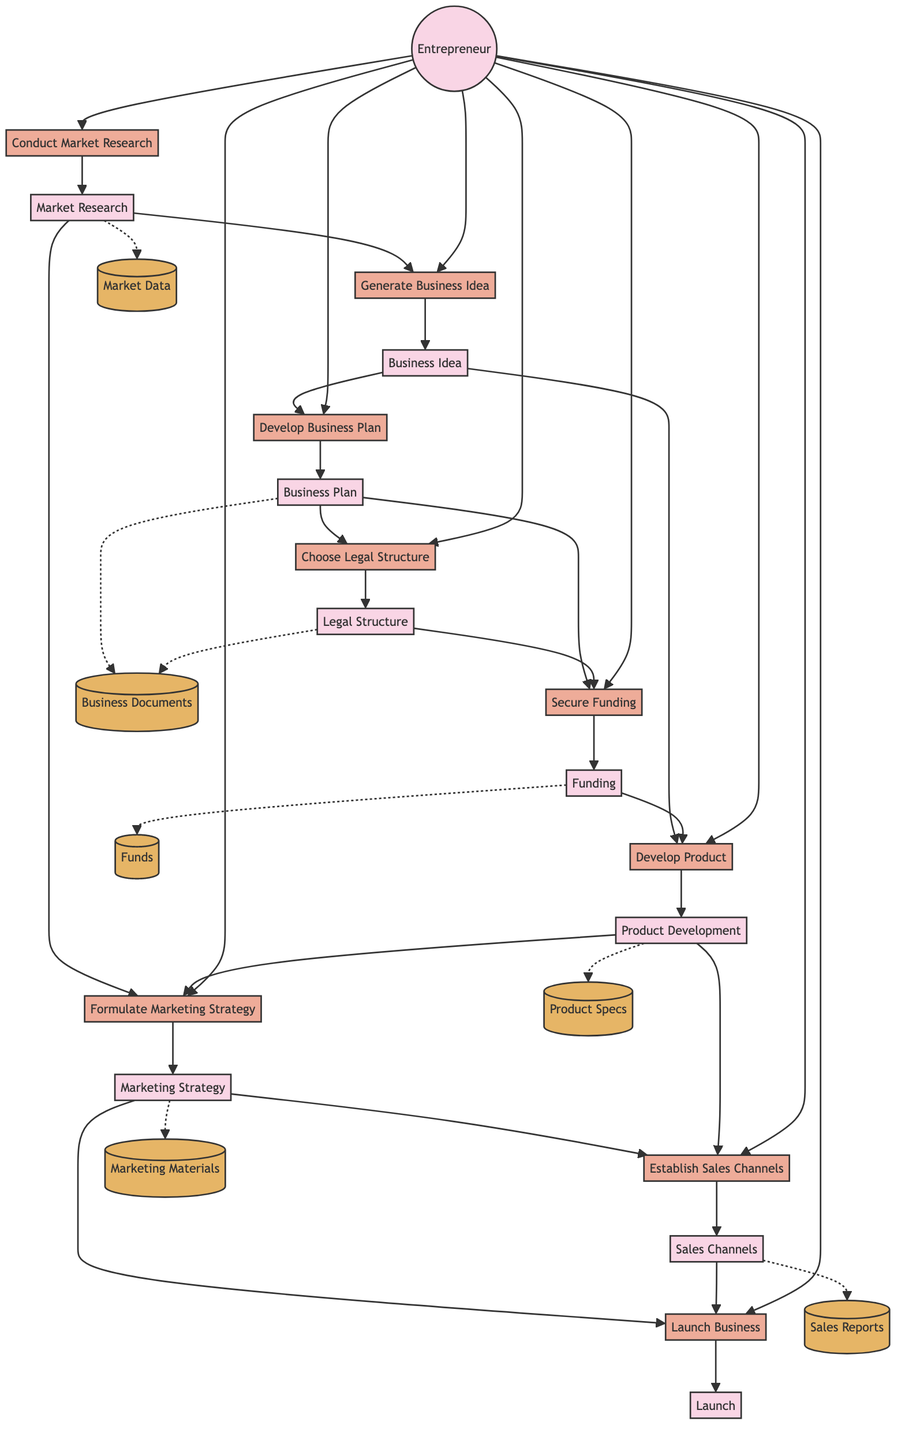What is the first process in the diagram? The first process is 'Conduct Market Research,' which takes the entrepreneur as input and outputs market research data.
Answer: Conduct Market Research How many entities are present in the diagram? Counting the entities illustrated, there are 10 entities in total listed in the diagram.
Answer: 10 Which process is dependent on both the Business Plan and Legal Structure? The 'Secure Funding' process requires both the Business Plan and Legal Structure as inputs to proceed and output funding.
Answer: Secure Funding What is the last output of the flow in the diagram? The final output is 'Launch,' which is the result of the 'Launch Business' process involving the entrepreneur, marketing strategy, and sales channels.
Answer: Launch How many data stores are featured in the diagram? The diagram illustrates a total of 6 data stores related to various business aspects throughout the process.
Answer: 6 What does the 'Develop Product' process require as inputs? The inputs needed for 'Develop Product' are the Entrepreneur, Business Idea, and Funding, all of which must be present for the product development to occur.
Answer: Entrepreneur, Business Idea, Funding What entity initiates the 'Formulate Marketing Strategy' process? The 'Formulate Marketing Strategy' process begins with the inputs from the Entrepreneur, Market Research, and Product Development, highlighting the entrepreneur's role in initiating it.
Answer: Entrepreneur Which process feeds into the 'Sales Channels'? The 'Establish Sales Channels' process receives inputs from the Marketing Strategy and Product Development, illustrating its connections to established marketing and product specifications.
Answer: Establish Sales Channels How is 'Market Research' utilized throughout the diagram? 'Market Research' serves as an output from the 'Conduct Market Research' process and acts as an input for both the 'Generate Business Idea' and 'Formulate Marketing Strategy,' emphasizing its crucial role in guiding these processes.
Answer: Provides inputs for Business Idea and Marketing Strategy 